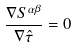<formula> <loc_0><loc_0><loc_500><loc_500>\frac { \nabla S ^ { \alpha \beta } } { \nabla \hat { \tau } } = 0</formula> 